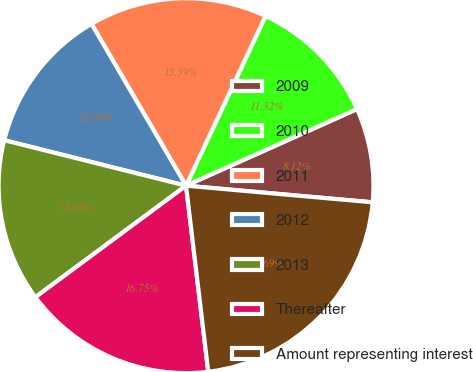Convert chart to OTSL. <chart><loc_0><loc_0><loc_500><loc_500><pie_chart><fcel>2009<fcel>2010<fcel>2011<fcel>2012<fcel>2013<fcel>Thereafter<fcel>Amount representing interest<nl><fcel>8.12%<fcel>11.32%<fcel>15.39%<fcel>12.68%<fcel>14.04%<fcel>16.75%<fcel>21.69%<nl></chart> 